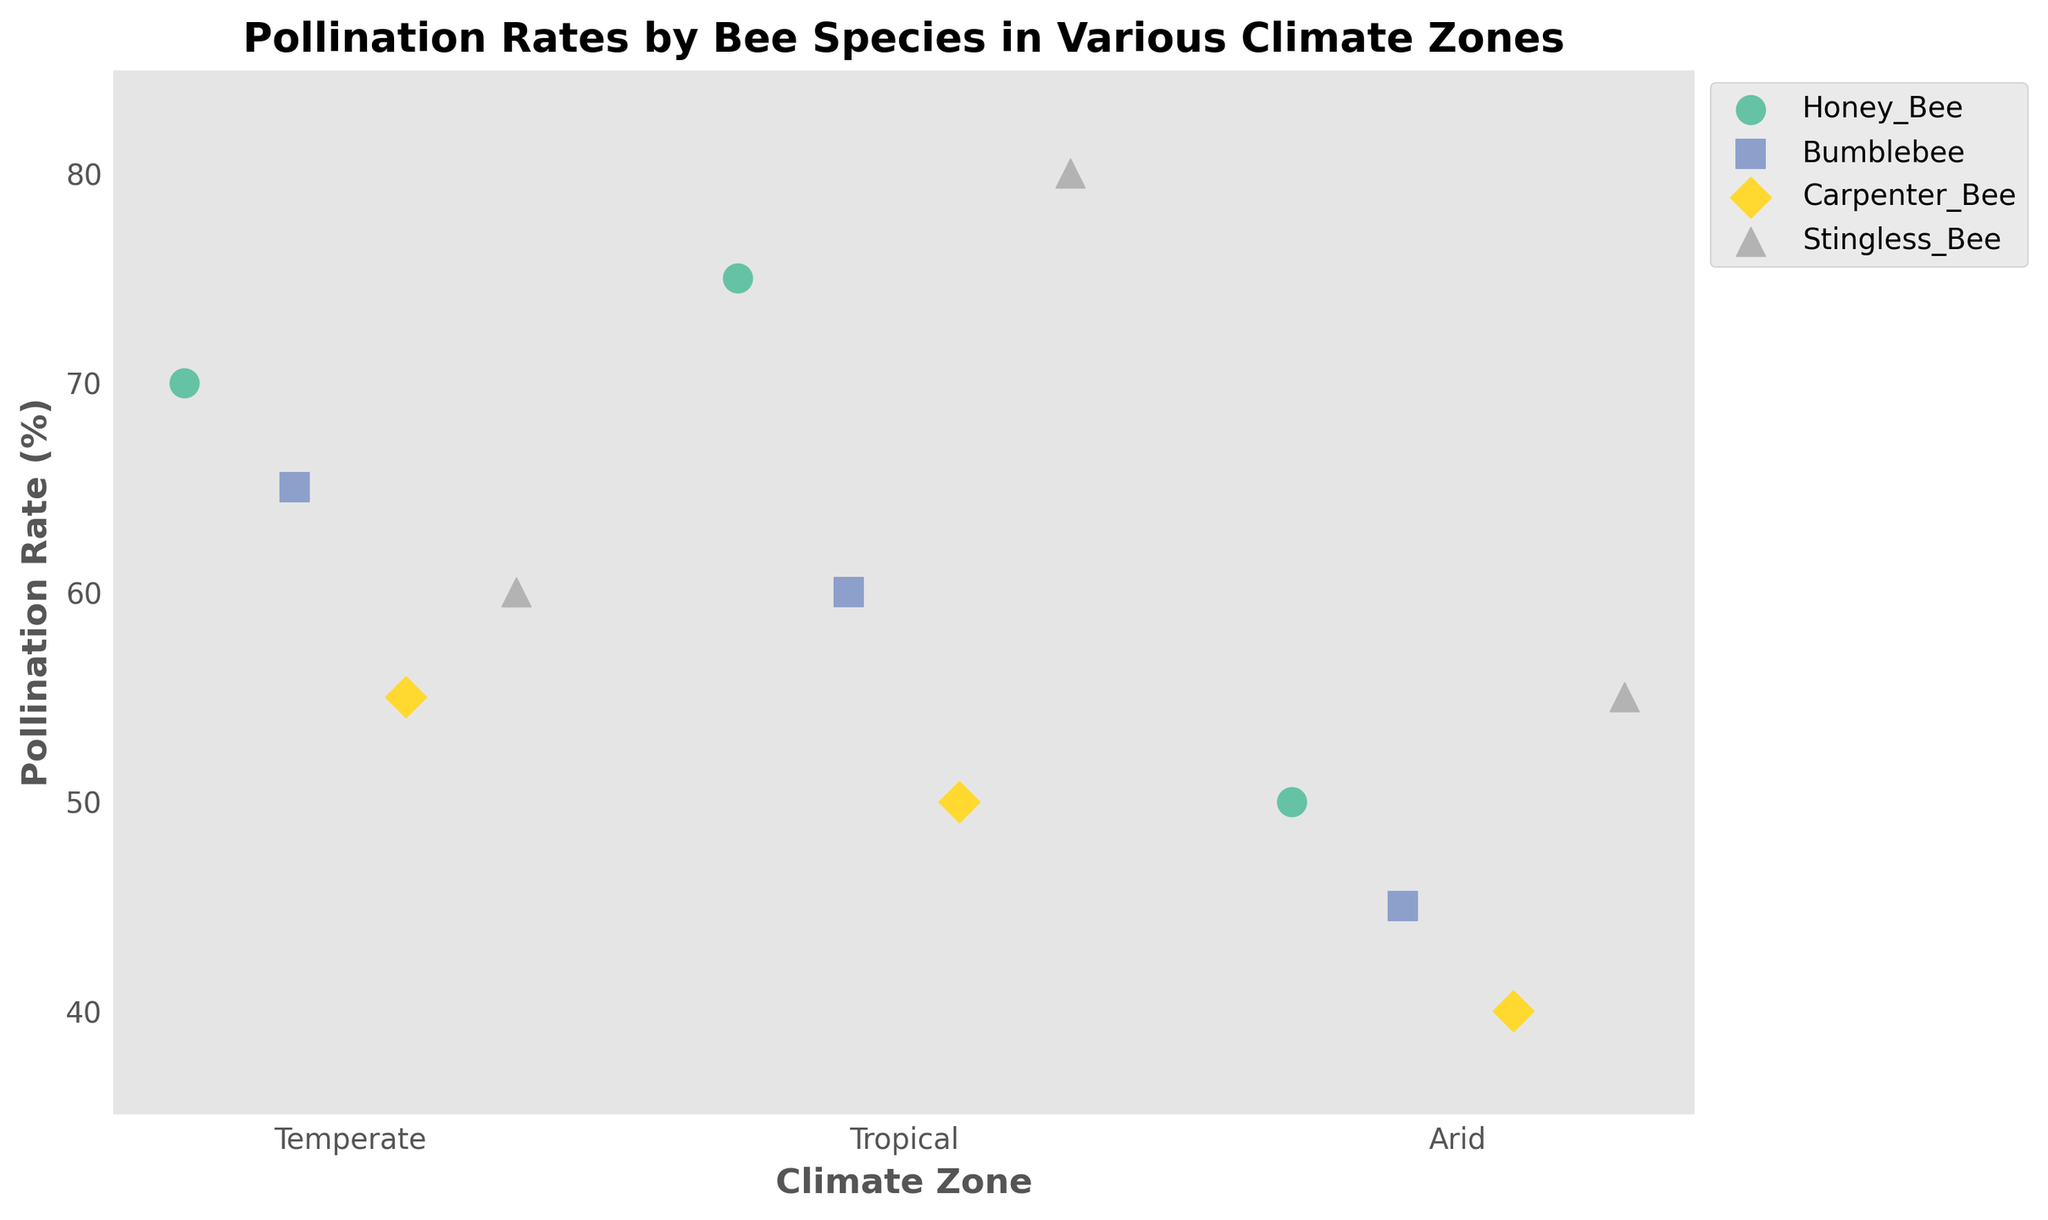What is the title of the plot? The title of the plot is typically found at the top of the figure. It provides a summary of what the plot is about. In this case, the title is clear from the given data and code.
Answer: Pollination Rates by Bee Species in Various Climate Zones Which bee species has the highest pollination rate in Tropical climate? To find the answer, look for the Tropical climate on the x-axis and compare the pollination rates of different species. The highest point will indicate the species with the highest rate.
Answer: Stingless_Bee What is the range of pollination rates for Honey Bees across all climate zones? Check the y-axis values for all points corresponding to Honey Bees across different climate zones. Identify the highest and lowest values to determine the range.
Answer: 50% to 75% Which climate zone shows the lowest pollination rate for Bumblebees? Locate the points for Bumblebees on the plot and identify which climate zone corresponds to the lowest y-axis value among them.
Answer: Arid How does the average pollination rate of Honey Bees compare to Carpenter Bees? Calculate the average pollination rate for both species by summing their pollination rates across all climate zones and dividing by the number of zones, then compare the two averages.
Answer: Honey Bees: 65%, Carpenter Bees: 48.33%; Honey Bees have a higher average Which bee species shows the most consistent pollination rates across different climate zones? Consistency can be gauged by observing the variance in pollination rates across different climates for each species. The species with the least variance has the most consistent rates.
Answer: Bumblebee What's the difference in pollination rates between the best performing and the worst performing species in Temperate climate? Identify the highest and lowest pollination rates in the Temperate climate zone and calculate their difference.
Answer: Honey_Bee (70%) - Carpenter_Bee (55%) = 15% Are there any species with increasing pollination rates from Arid to Tropical climate zones? Check each species' pollination rates sequentially from Arid to Temperate to Tropical climate zones. Identify if any species shows an overall increasing trend.
Answer: Stingless_Bee Which species performs better in Arid climate compared to their performance in Temperate climate? Compare the pollination rates for each species in Arid and Temperate climates and see if any species has a better performance in Arid.
Answer: No species performs better in Arid compared to Temperate 